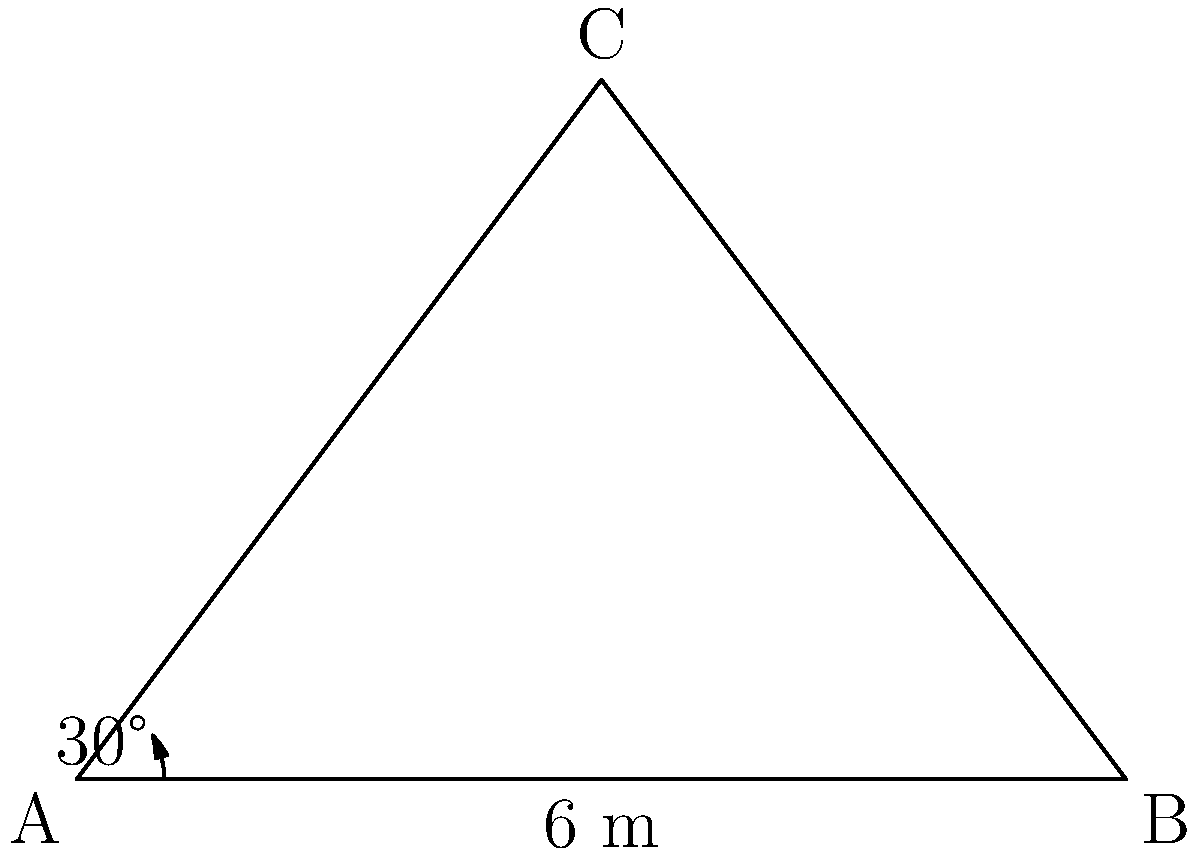As a florist, you're setting up a beautiful wedding arch for an outdoor ceremony. The base of the arch is 6 meters wide, and you know that the angle between the ground and the side of the arch is 30°. Using trigonometric ratios, calculate the height of the wedding arch to ensure it's tall enough for the bride and groom to stand under comfortably. Let's approach this step-by-step:

1) First, we need to identify the trigonometric ratio we'll use. In this case, we're looking for the height of the arch, which is the opposite side to the 30° angle in a right-angled triangle.

2) We know the base of the arch, which is 6 meters. This forms the hypotenuse of our right-angled triangle.

3) The ratio we'll use is sine, as it relates the opposite side (height) to the hypotenuse (base of the arch):

   $\sin \theta = \frac{\text{opposite}}{\text{hypotenuse}}$

4) We can write this as an equation:

   $\sin 30° = \frac{\text{height}}{6}$

5) To solve for the height, we multiply both sides by 6:

   $6 \sin 30° = \text{height}$

6) We know that $\sin 30° = \frac{1}{2}$, so:

   $6 \cdot \frac{1}{2} = \text{height}$

7) Therefore:

   $\text{height} = 3$ meters

So, the wedding arch will be 3 meters tall, which should be plenty of room for the happy couple to stand under!
Answer: 3 meters 